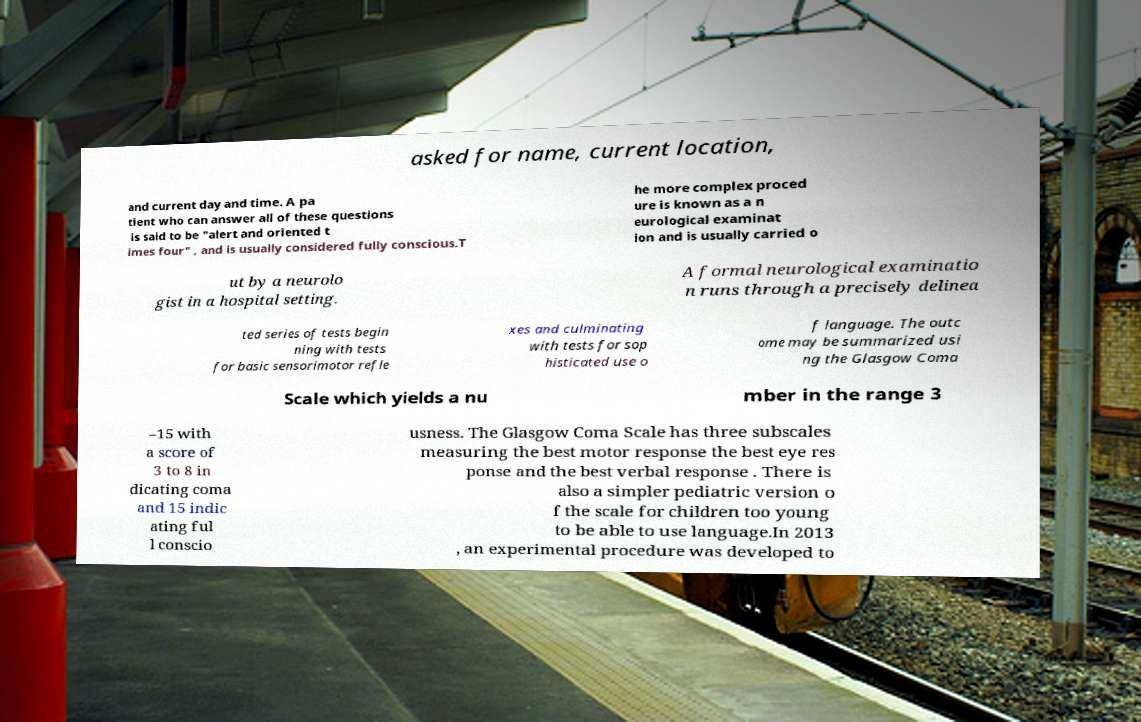Could you extract and type out the text from this image? asked for name, current location, and current day and time. A pa tient who can answer all of these questions is said to be "alert and oriented t imes four" , and is usually considered fully conscious.T he more complex proced ure is known as a n eurological examinat ion and is usually carried o ut by a neurolo gist in a hospital setting. A formal neurological examinatio n runs through a precisely delinea ted series of tests begin ning with tests for basic sensorimotor refle xes and culminating with tests for sop histicated use o f language. The outc ome may be summarized usi ng the Glasgow Coma Scale which yields a nu mber in the range 3 –15 with a score of 3 to 8 in dicating coma and 15 indic ating ful l conscio usness. The Glasgow Coma Scale has three subscales measuring the best motor response the best eye res ponse and the best verbal response . There is also a simpler pediatric version o f the scale for children too young to be able to use language.In 2013 , an experimental procedure was developed to 